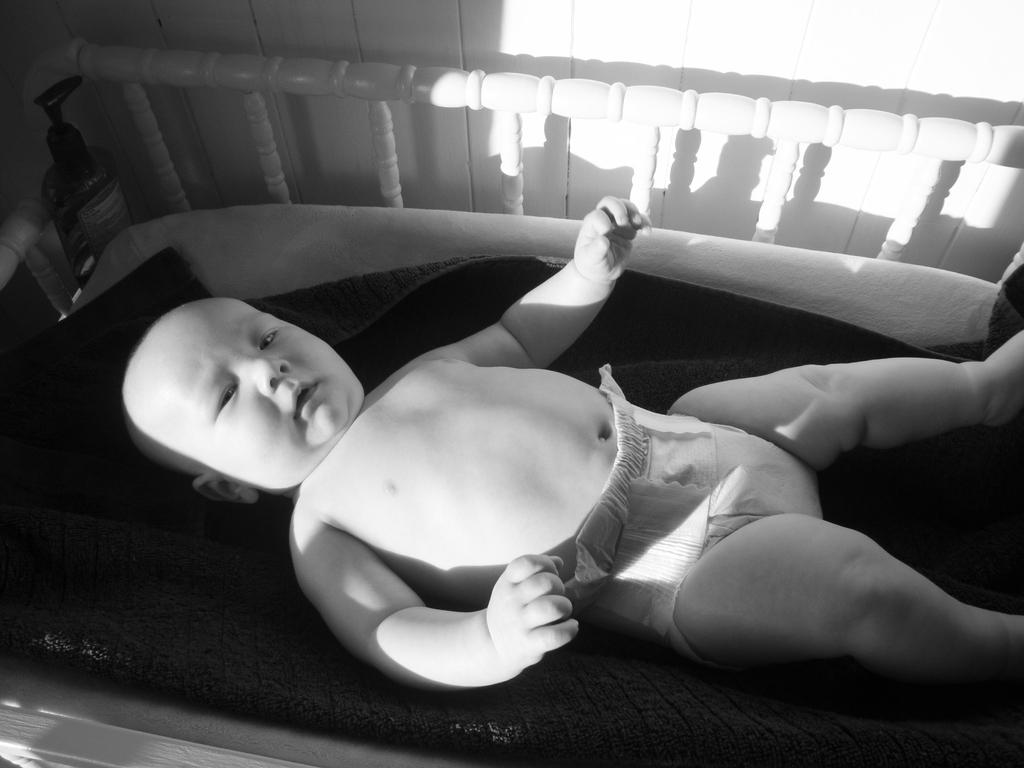What is the main subject of the image? There is a baby in the image. What is the baby lying on or near? There is a bed in the image. What type of wall can be seen in the image? There is a wooden wall in the image. What type of branch is the baby holding in the image? There is no branch present in the image; the baby is lying on a bed near a wooden wall. 